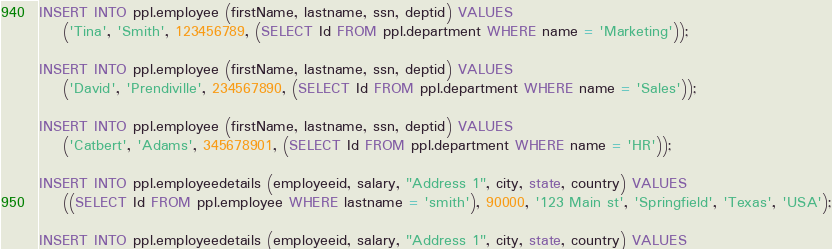<code> <loc_0><loc_0><loc_500><loc_500><_SQL_>INSERT INTO ppl.employee (firstName, lastname, ssn, deptid) VALUES
	('Tina', 'Smith', 123456789, (SELECT Id FROM ppl.department WHERE name = 'Marketing'));

INSERT INTO ppl.employee (firstName, lastname, ssn, deptid) VALUES
	('David', 'Prendiville', 234567890, (SELECT Id FROM ppl.department WHERE name = 'Sales'));

INSERT INTO ppl.employee (firstName, lastname, ssn, deptid) VALUES
	('Catbert', 'Adams', 345678901, (SELECT Id FROM ppl.department WHERE name = 'HR'));

INSERT INTO ppl.employeedetails (employeeid, salary, "Address 1", city, state, country) VALUES
	((SELECT Id FROM ppl.employee WHERE lastname = 'smith'), 90000, '123 Main st', 'Springfield', 'Texas', 'USA');

INSERT INTO ppl.employeedetails (employeeid, salary, "Address 1", city, state, country) VALUES</code> 